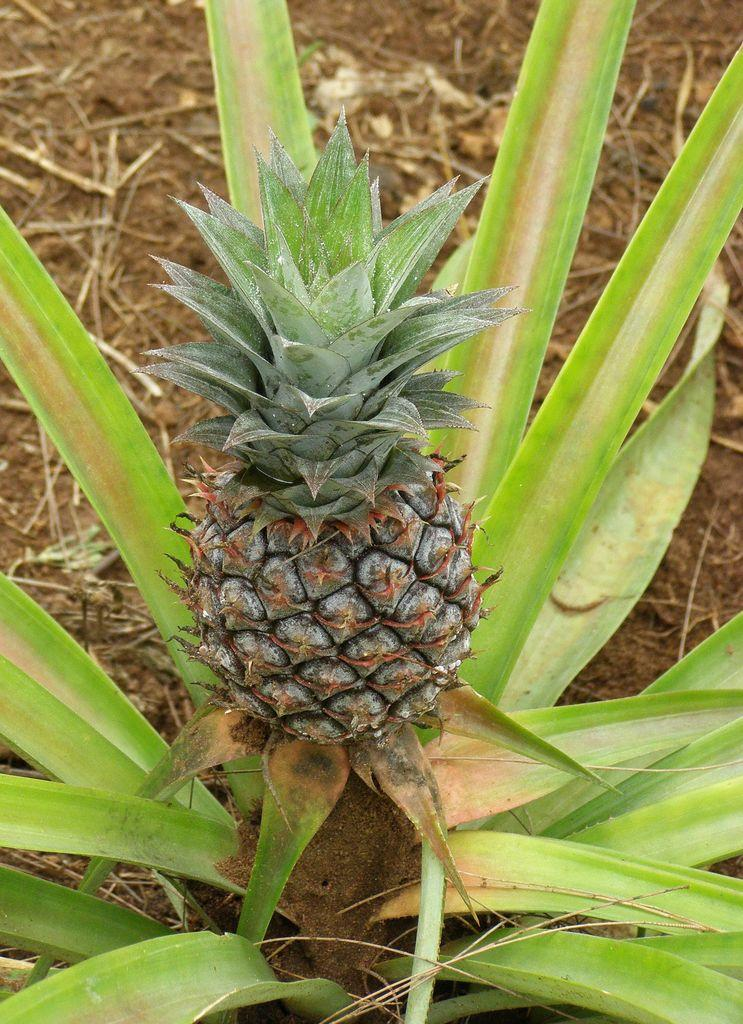What type of food is visible in the image? There is a fruit in the image. What other living organism can be seen in the image? There is a plant in the image. What type of vegetation is present in the background of the image? There is dry grass in the background of the image. What type of writing instrument is the writer using in the image? There is no writer or writing instrument present in the image. How many women are visible in the image? There are no women visible in the image. 